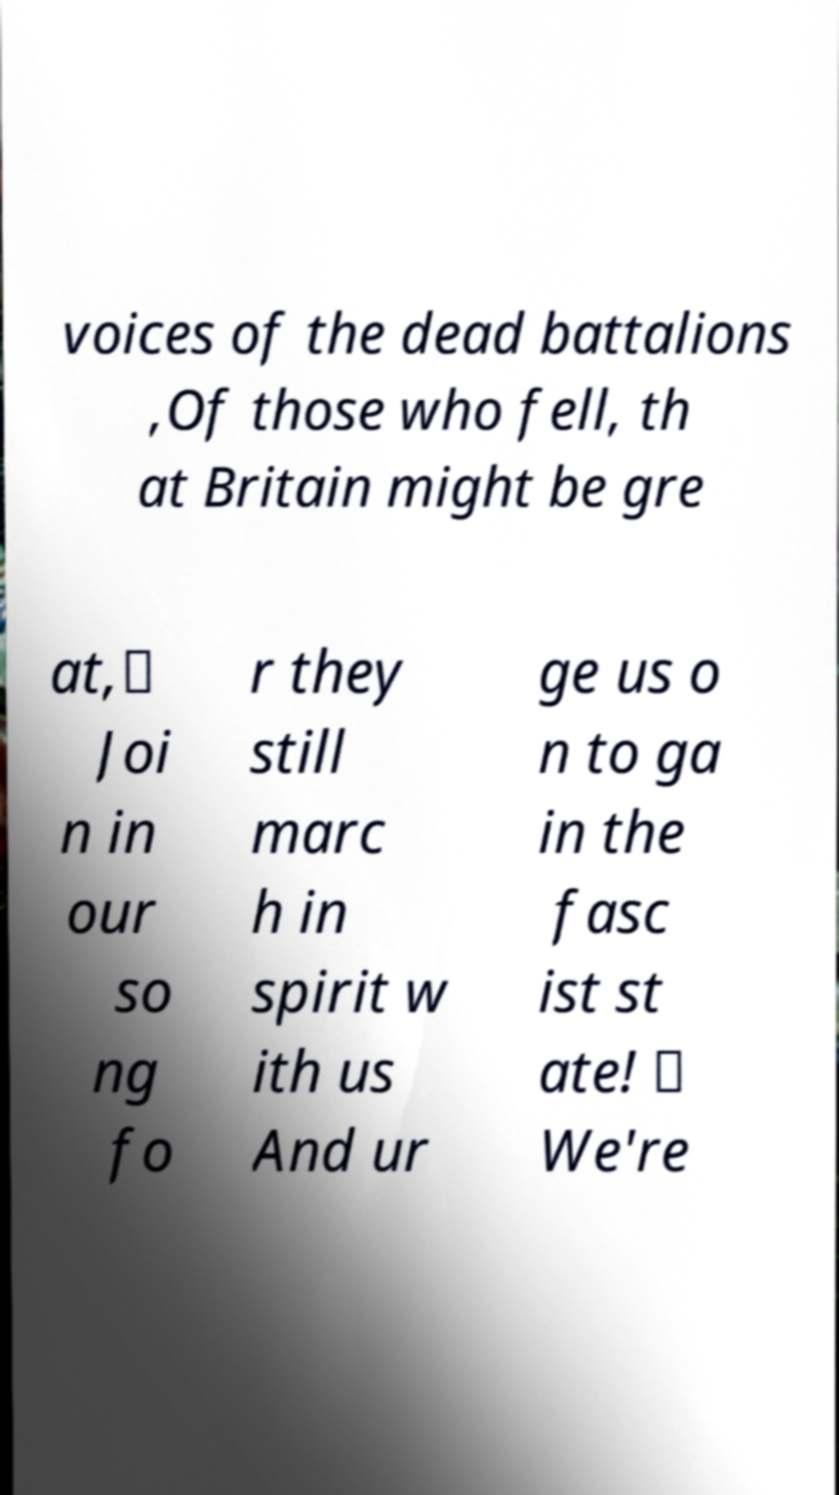Can you read and provide the text displayed in the image?This photo seems to have some interesting text. Can you extract and type it out for me? voices of the dead battalions ,Of those who fell, th at Britain might be gre at,𝄆 Joi n in our so ng fo r they still marc h in spirit w ith us And ur ge us o n to ga in the fasc ist st ate! 𝄇 We're 